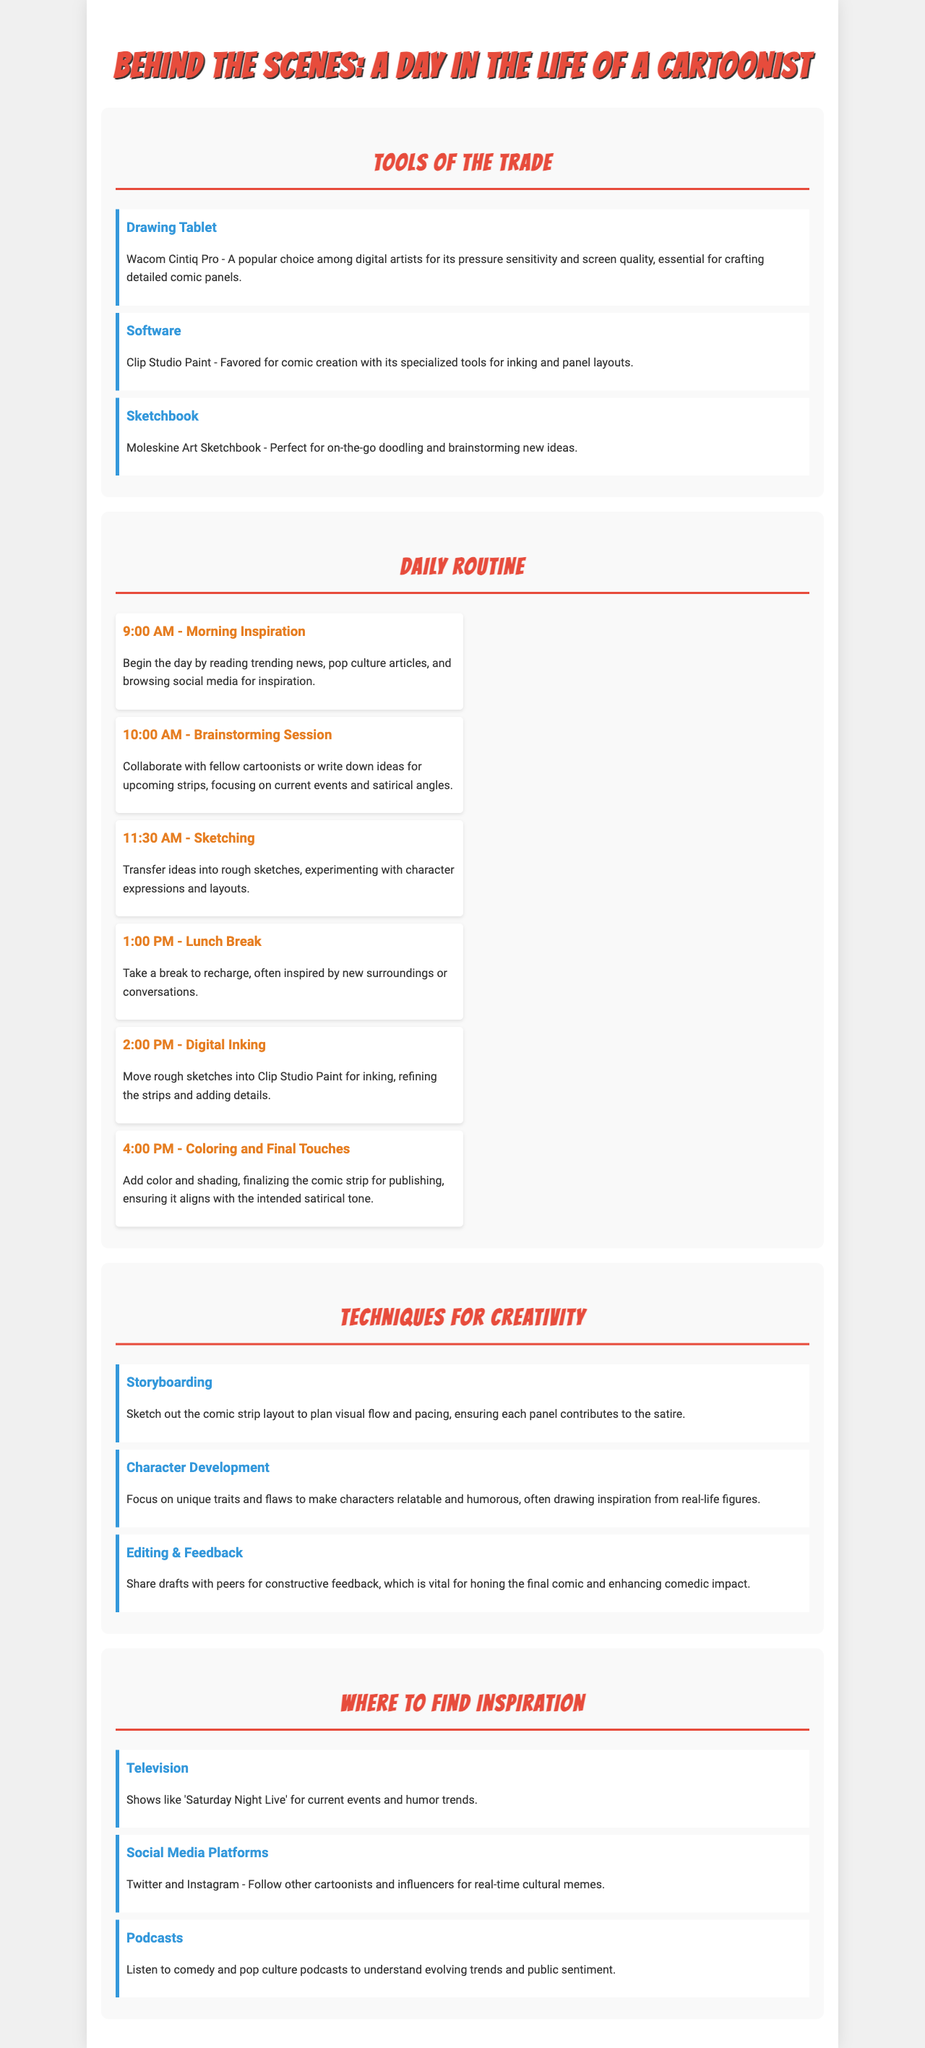What tool is mentioned for digital inking? The document lists Clip Studio Paint as the software favored for comic creation, including inking.
Answer: Clip Studio Paint What time does the cartoonist take a lunch break? The daily routine specifies that the lunch break occurs at 1:00 PM.
Answer: 1:00 PM Which sketchbook is preferred for brainstorming ideas? The brochure mentions Moleskine Art Sketchbook as the perfect choice for on-the-go doodling and brainstorming.
Answer: Moleskine Art Sketchbook What technique involves sketching out the comic strip layout? The document refers to storyboarding as the technique used to plan visual flow and pacing.
Answer: Storyboarding How many items are listed in the Tools of the Trade section? There are three items detailed under the Tools of the Trade section in the document.
Answer: 3 What is a vital part of enhancing the comedic impact of the comic? The document states that sharing drafts with peers for constructive feedback is vital for honing the final comic.
Answer: Feedback What is a key source of inspiration mentioned for current events and humor trends? The document mentions 'Saturday Night Live' as a source for inspiration regarding current events and humor trends.
Answer: Saturday Night Live What is the color used for the section titles? The document states that the section titles are in the color #e74c3c.
Answer: #e74c3c 